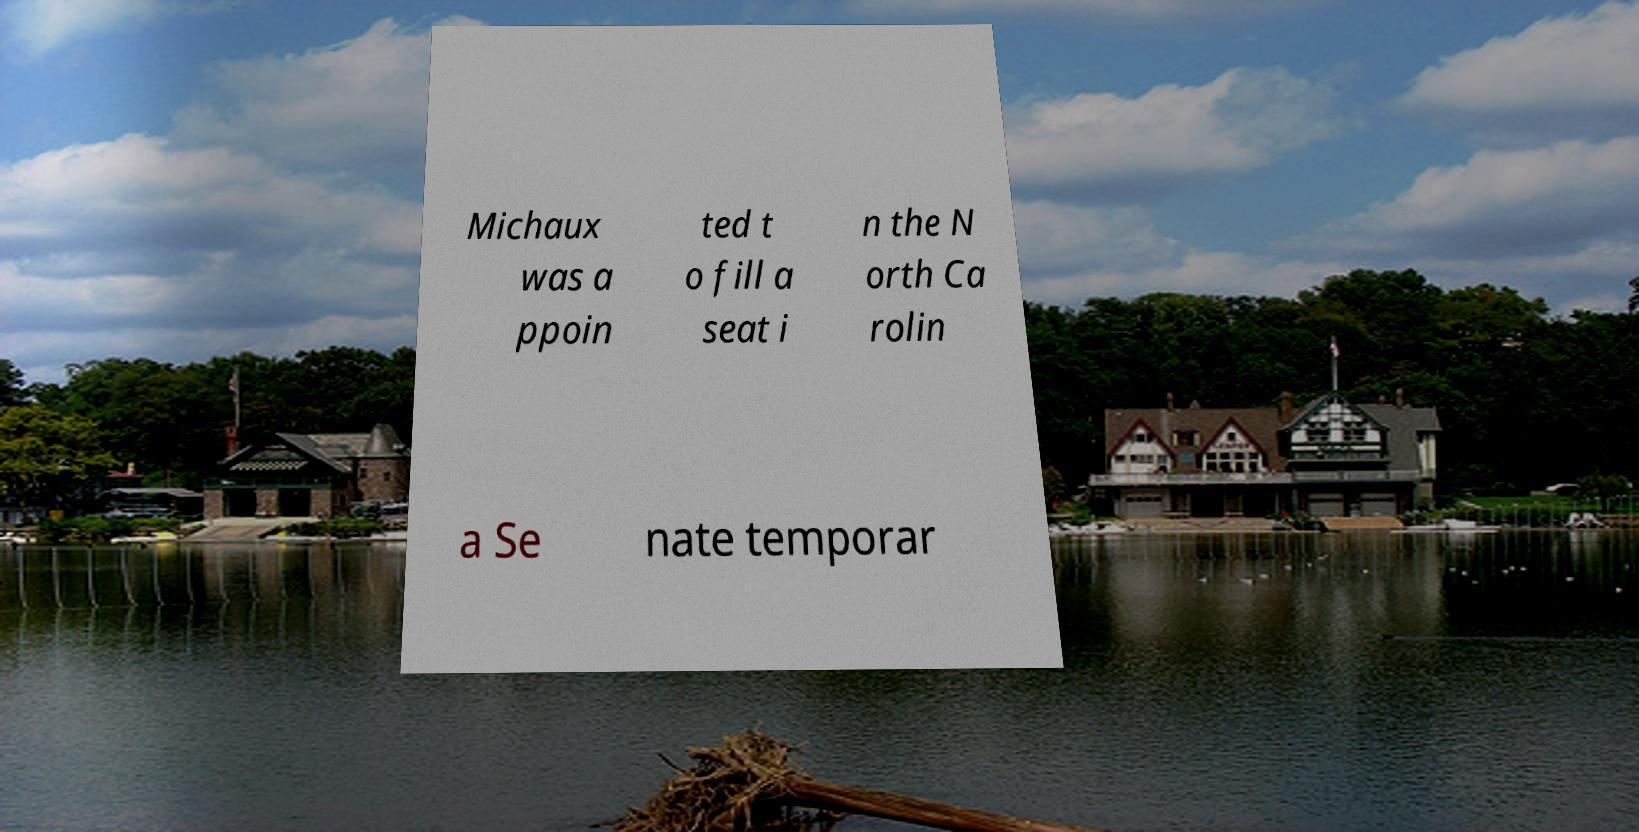There's text embedded in this image that I need extracted. Can you transcribe it verbatim? Michaux was a ppoin ted t o fill a seat i n the N orth Ca rolin a Se nate temporar 